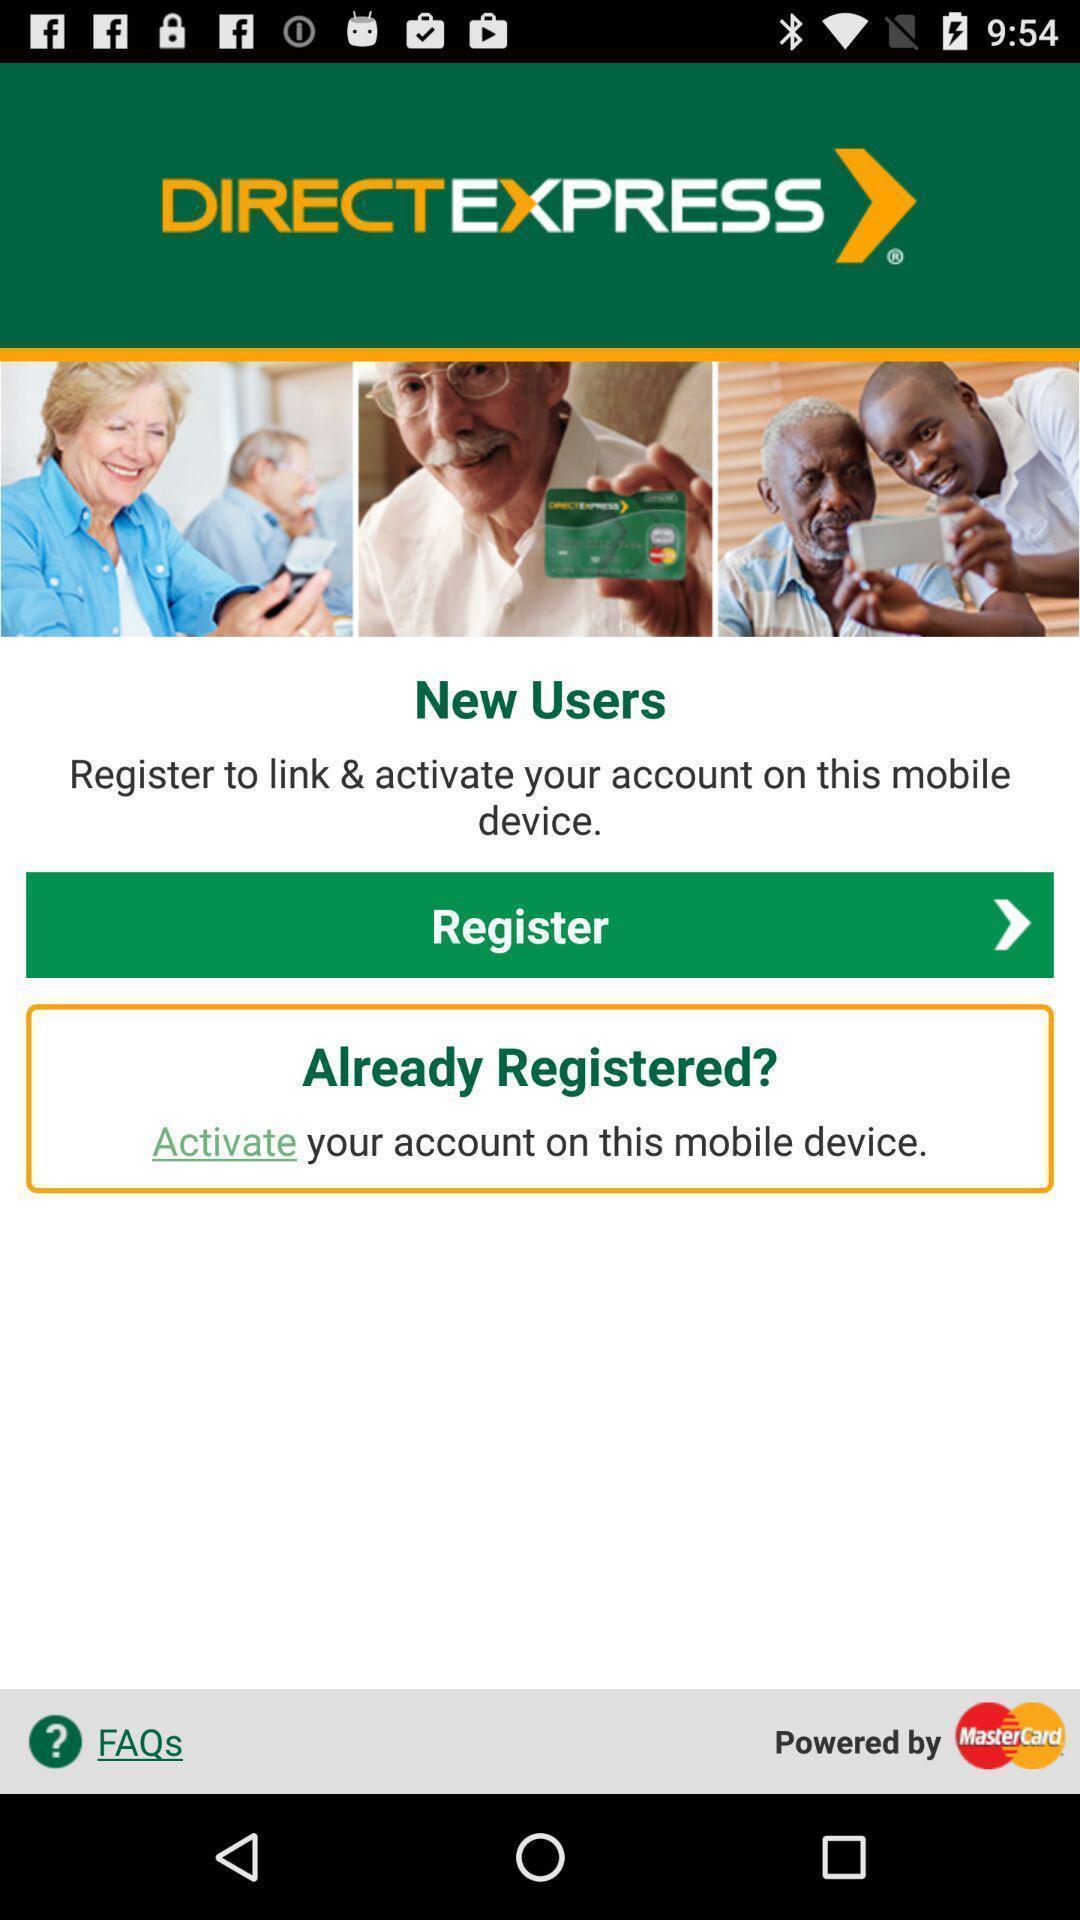Give me a summary of this screen capture. Screen of registration with activate option. 